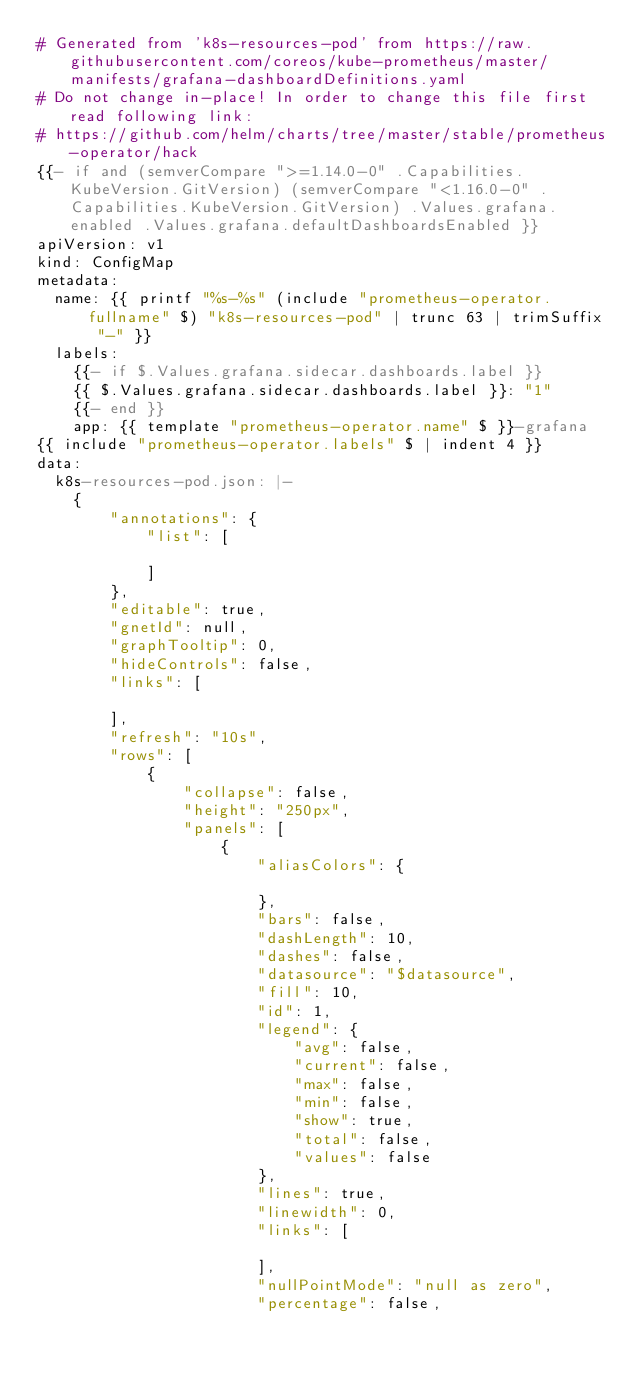<code> <loc_0><loc_0><loc_500><loc_500><_YAML_># Generated from 'k8s-resources-pod' from https://raw.githubusercontent.com/coreos/kube-prometheus/master/manifests/grafana-dashboardDefinitions.yaml
# Do not change in-place! In order to change this file first read following link:
# https://github.com/helm/charts/tree/master/stable/prometheus-operator/hack
{{- if and (semverCompare ">=1.14.0-0" .Capabilities.KubeVersion.GitVersion) (semverCompare "<1.16.0-0" .Capabilities.KubeVersion.GitVersion) .Values.grafana.enabled .Values.grafana.defaultDashboardsEnabled }}
apiVersion: v1
kind: ConfigMap
metadata:
  name: {{ printf "%s-%s" (include "prometheus-operator.fullname" $) "k8s-resources-pod" | trunc 63 | trimSuffix "-" }}
  labels:
    {{- if $.Values.grafana.sidecar.dashboards.label }}
    {{ $.Values.grafana.sidecar.dashboards.label }}: "1"
    {{- end }}
    app: {{ template "prometheus-operator.name" $ }}-grafana
{{ include "prometheus-operator.labels" $ | indent 4 }}
data:
  k8s-resources-pod.json: |-
    {
        "annotations": {
            "list": [

            ]
        },
        "editable": true,
        "gnetId": null,
        "graphTooltip": 0,
        "hideControls": false,
        "links": [

        ],
        "refresh": "10s",
        "rows": [
            {
                "collapse": false,
                "height": "250px",
                "panels": [
                    {
                        "aliasColors": {

                        },
                        "bars": false,
                        "dashLength": 10,
                        "dashes": false,
                        "datasource": "$datasource",
                        "fill": 10,
                        "id": 1,
                        "legend": {
                            "avg": false,
                            "current": false,
                            "max": false,
                            "min": false,
                            "show": true,
                            "total": false,
                            "values": false
                        },
                        "lines": true,
                        "linewidth": 0,
                        "links": [

                        ],
                        "nullPointMode": "null as zero",
                        "percentage": false,</code> 